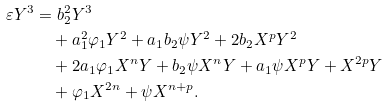Convert formula to latex. <formula><loc_0><loc_0><loc_500><loc_500>\varepsilon Y ^ { 3 } = & \ b _ { 2 } ^ { 2 } Y ^ { 3 } \\ & + a _ { 1 } ^ { 2 } \varphi _ { 1 } Y ^ { 2 } + a _ { 1 } b _ { 2 } \psi Y ^ { 2 } + 2 b _ { 2 } X ^ { p } Y ^ { 2 } \\ & + 2 a _ { 1 } \varphi _ { 1 } X ^ { n } Y + b _ { 2 } \psi X ^ { n } Y + a _ { 1 } \psi X ^ { p } Y + X ^ { 2 p } Y \\ & + \varphi _ { 1 } X ^ { 2 n } + \psi X ^ { n + p } .</formula> 